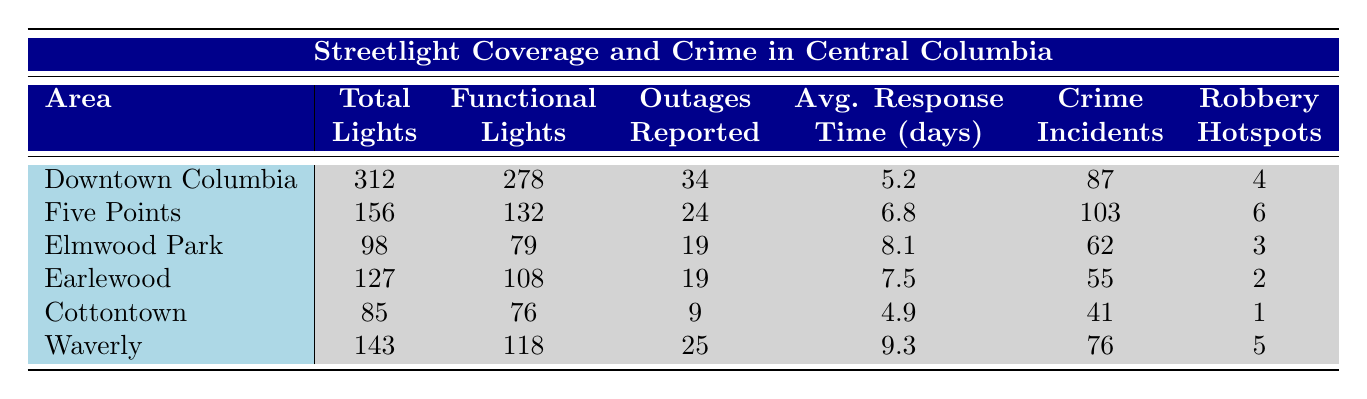What area has the highest number of total streetlights? By examining the 'Total streetlights' column, we can see that Downtown Columbia has the highest value, which is 312.
Answer: Downtown Columbia How many functional streetlights are there in Elmwood Park? From the table, the value in the 'Functional streetlights' column for Elmwood Park is 79.
Answer: 79 Which area has the fewest streetlight outages reported? Looking at the 'Streetlight outages reported' column, Cottontown has the lowest value of 9 outages reported.
Answer: Cottontown What is the average response time for streetlight repair in Waverly? The 'Average response time (days)' for Waverly listed in the table is 9.3 days.
Answer: 9.3 days How many crime incidents were reported in total across all areas? Summing the values from the 'Crime incidents (last 6 months)' column gives us 87 + 103 + 62 + 55 + 41 + 76 = 424 incidents.
Answer: 424 Is the number of functional streetlights in Five Points greater than the number of functional streetlights in Earlewood? In the table, Five Points has 132 functional streetlights while Earlewood has 108. Since 132 is greater than 108, the statement is true.
Answer: Yes What is the difference in the number of total streetlights between Downtown Columbia and Cottontown? The total streetlights in Downtown Columbia is 312 and in Cottontown, it is 85. The difference is 312 - 85 = 227.
Answer: 227 Which area has more robbery hotspots, Five Points or Waverly? In the 'Robbery hotspots' column, Five Points has 6 hotspots, whereas Waverly has 5 hotspots, so Five Points has more hotspots.
Answer: Five Points What is the average number of functional streetlights across all six areas? To find the average, we first sum the functional streetlights: 278 + 132 + 79 + 108 + 76 + 118 = 791. There are 6 areas, so the average is 791 / 6 = 131.83.
Answer: 131.83 Which area has the highest number of reported streetlight outages? By comparing the values in the 'Streetlight outages reported' column, Downtown Columbia has the highest number of reported outages, which is 34.
Answer: Downtown Columbia 